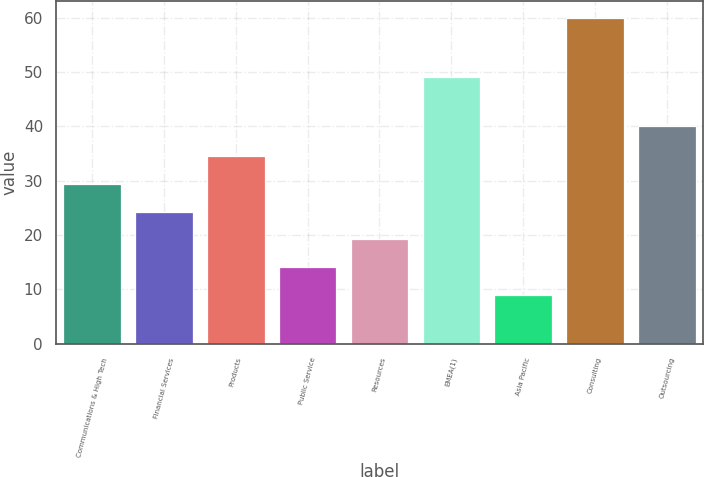Convert chart to OTSL. <chart><loc_0><loc_0><loc_500><loc_500><bar_chart><fcel>Communications & High Tech<fcel>Financial Services<fcel>Products<fcel>Public Service<fcel>Resources<fcel>EMEA(1)<fcel>Asia Pacific<fcel>Consulting<fcel>Outsourcing<nl><fcel>29.4<fcel>24.3<fcel>34.5<fcel>14.1<fcel>19.2<fcel>49<fcel>9<fcel>60<fcel>40<nl></chart> 